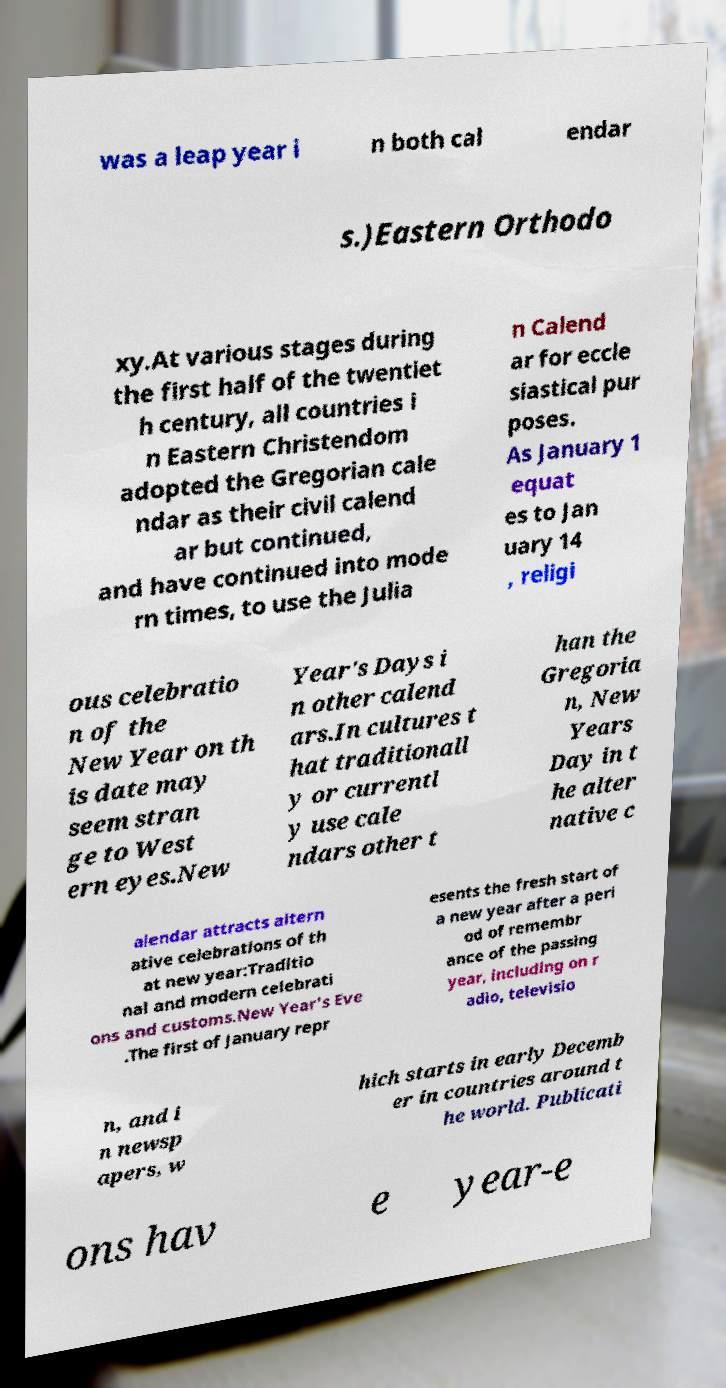For documentation purposes, I need the text within this image transcribed. Could you provide that? was a leap year i n both cal endar s.)Eastern Orthodo xy.At various stages during the first half of the twentiet h century, all countries i n Eastern Christendom adopted the Gregorian cale ndar as their civil calend ar but continued, and have continued into mode rn times, to use the Julia n Calend ar for eccle siastical pur poses. As January 1 equat es to Jan uary 14 , religi ous celebratio n of the New Year on th is date may seem stran ge to West ern eyes.New Year's Days i n other calend ars.In cultures t hat traditionall y or currentl y use cale ndars other t han the Gregoria n, New Years Day in t he alter native c alendar attracts altern ative celebrations of th at new year:Traditio nal and modern celebrati ons and customs.New Year's Eve .The first of January repr esents the fresh start of a new year after a peri od of remembr ance of the passing year, including on r adio, televisio n, and i n newsp apers, w hich starts in early Decemb er in countries around t he world. Publicati ons hav e year-e 